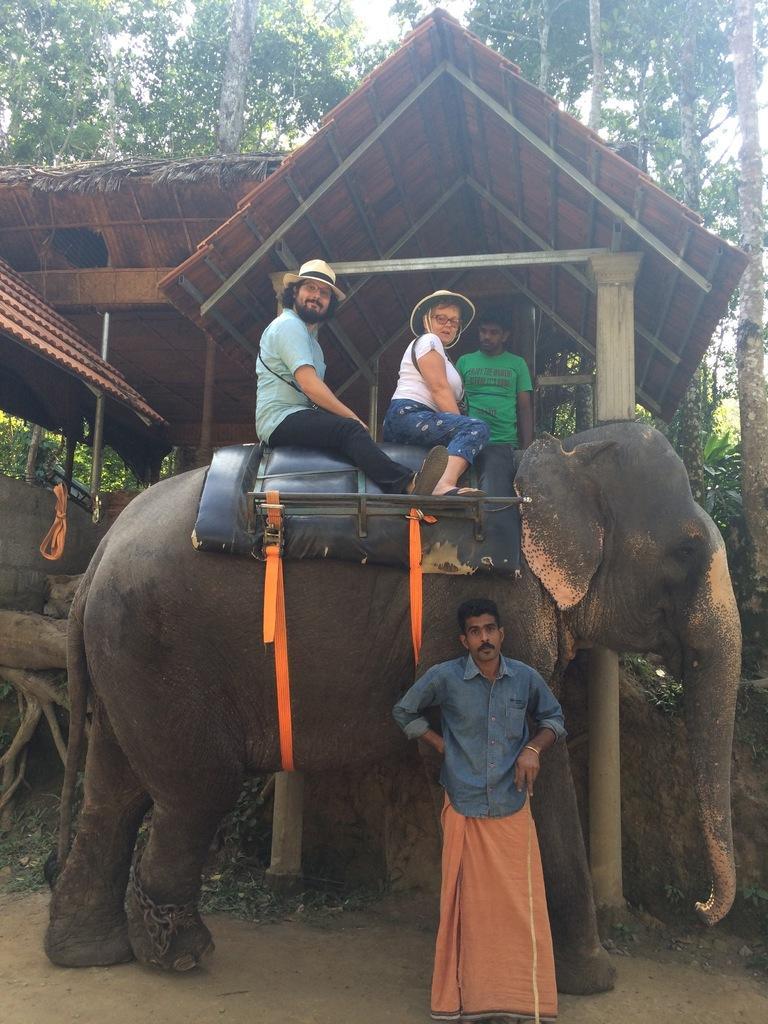How would you summarize this image in a sentence or two? In this image there is a elephant and a mahout there are two persons sitting on the elephant and a person standing behind the elephant and at the background of the image there is a hut and trees. 